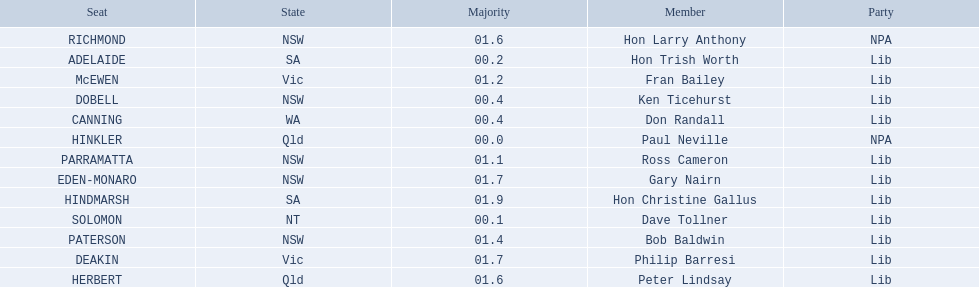Which seats are represented in the electoral system of australia? HINKLER, SOLOMON, ADELAIDE, CANNING, DOBELL, PARRAMATTA, McEWEN, PATERSON, HERBERT, RICHMOND, DEAKIN, EDEN-MONARO, HINDMARSH. What were their majority numbers of both hindmarsh and hinkler? HINKLER, HINDMARSH. Of those two seats, what is the difference in voting majority? 01.9. 